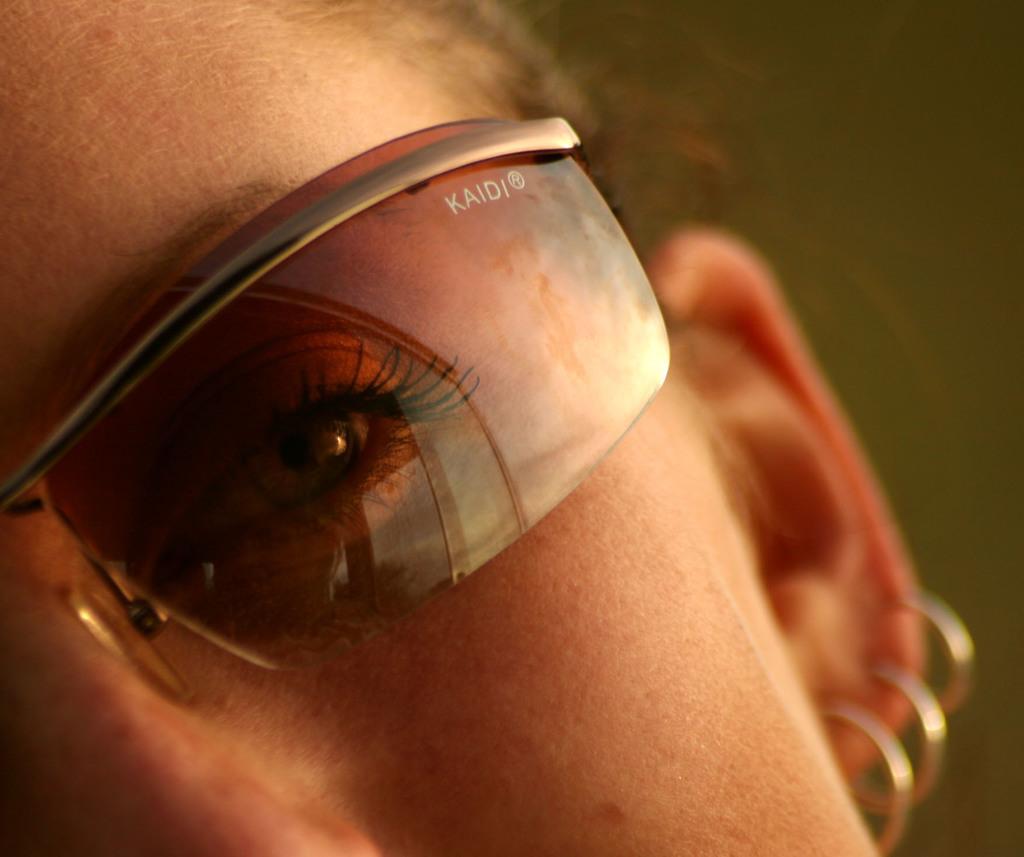Please provide a concise description of this image. In this picture we can see a person face, spectacles, earrings and in the background it is blurry. 